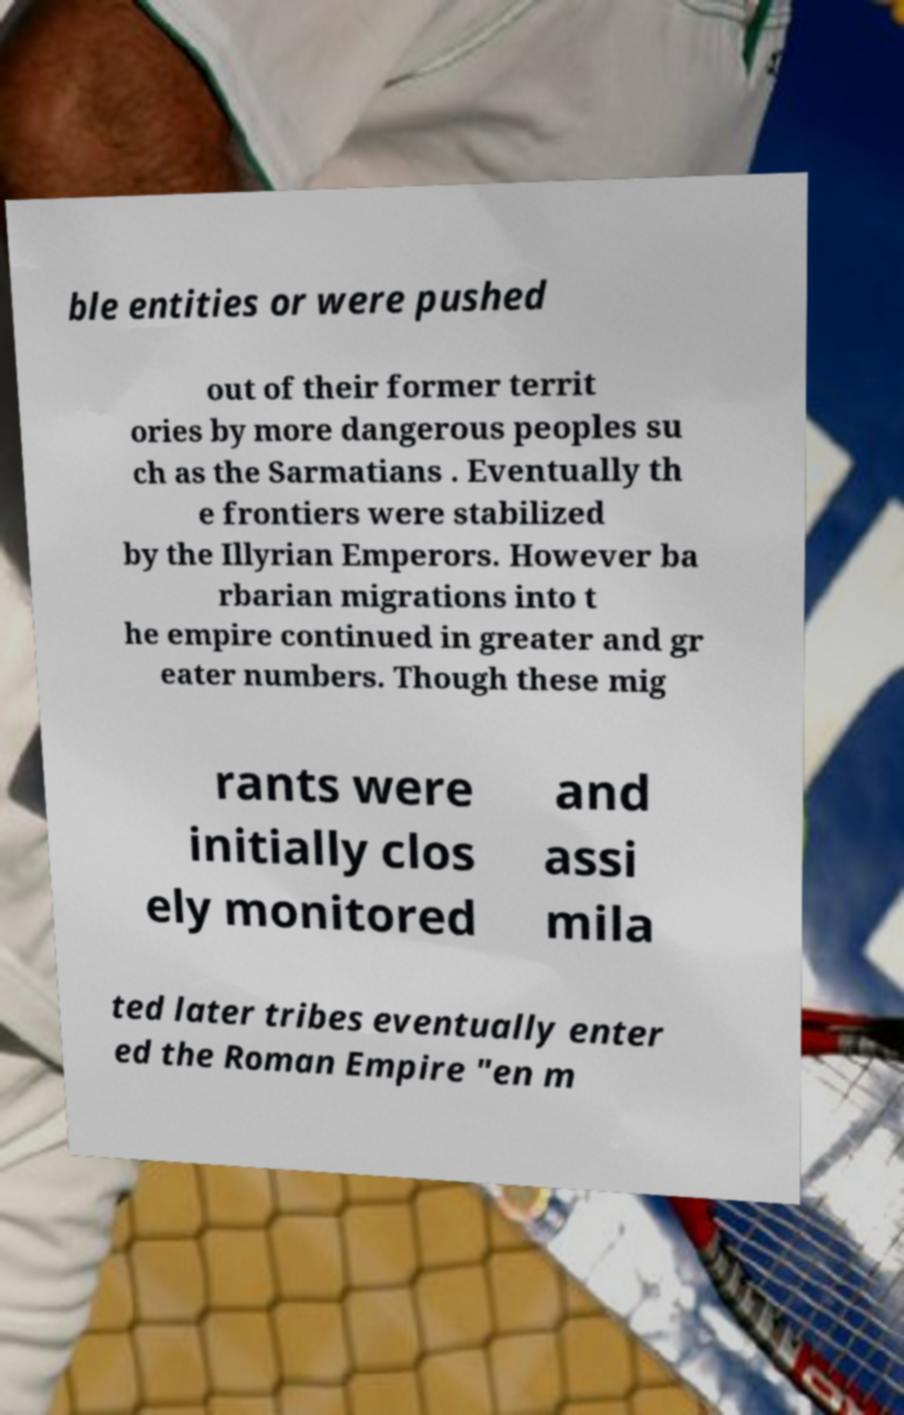Could you assist in decoding the text presented in this image and type it out clearly? ble entities or were pushed out of their former territ ories by more dangerous peoples su ch as the Sarmatians . Eventually th e frontiers were stabilized by the Illyrian Emperors. However ba rbarian migrations into t he empire continued in greater and gr eater numbers. Though these mig rants were initially clos ely monitored and assi mila ted later tribes eventually enter ed the Roman Empire "en m 